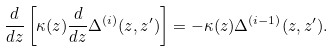<formula> <loc_0><loc_0><loc_500><loc_500>\frac { d } { d z } \left [ \kappa ( z ) \frac { d } { d z } \Delta ^ { ( i ) } ( z , z ^ { \prime } ) \right ] = - \kappa ( z ) \Delta ^ { ( i - 1 ) } ( z , z ^ { \prime } ) .</formula> 